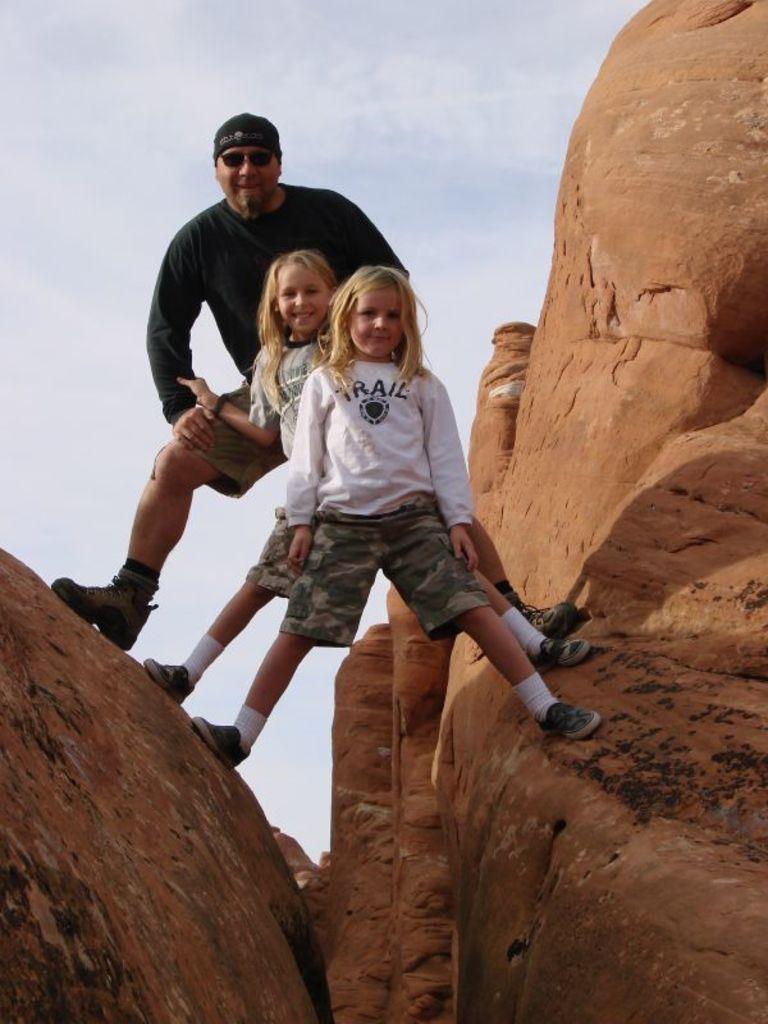In one or two sentences, can you explain what this image depicts? In this picture we can see a man and two girls on the hills. We can see the sky on top of the picture. 